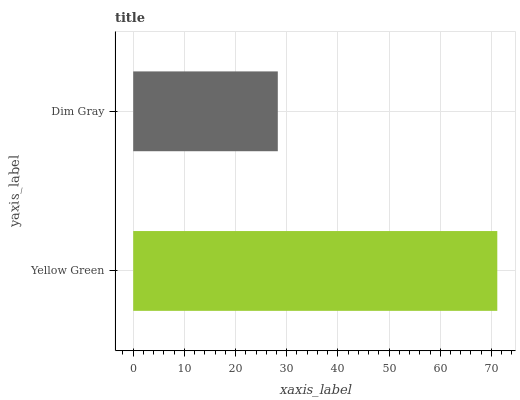Is Dim Gray the minimum?
Answer yes or no. Yes. Is Yellow Green the maximum?
Answer yes or no. Yes. Is Dim Gray the maximum?
Answer yes or no. No. Is Yellow Green greater than Dim Gray?
Answer yes or no. Yes. Is Dim Gray less than Yellow Green?
Answer yes or no. Yes. Is Dim Gray greater than Yellow Green?
Answer yes or no. No. Is Yellow Green less than Dim Gray?
Answer yes or no. No. Is Yellow Green the high median?
Answer yes or no. Yes. Is Dim Gray the low median?
Answer yes or no. Yes. Is Dim Gray the high median?
Answer yes or no. No. Is Yellow Green the low median?
Answer yes or no. No. 